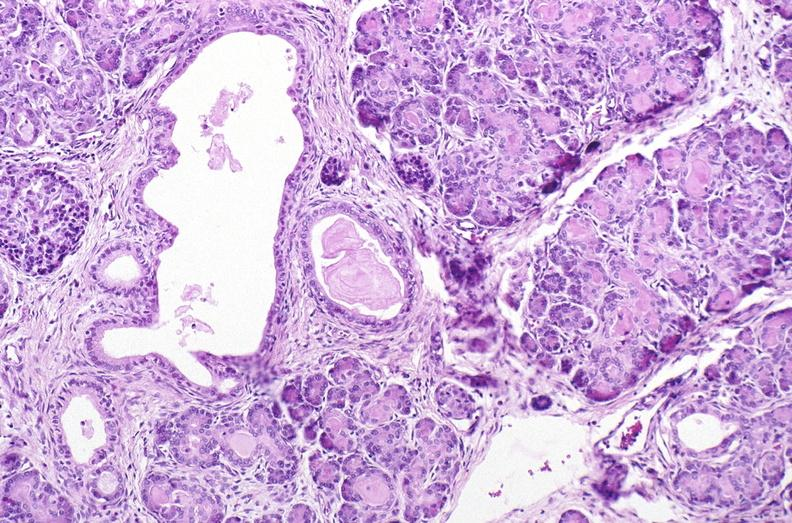what is present?
Answer the question using a single word or phrase. Pancreas 